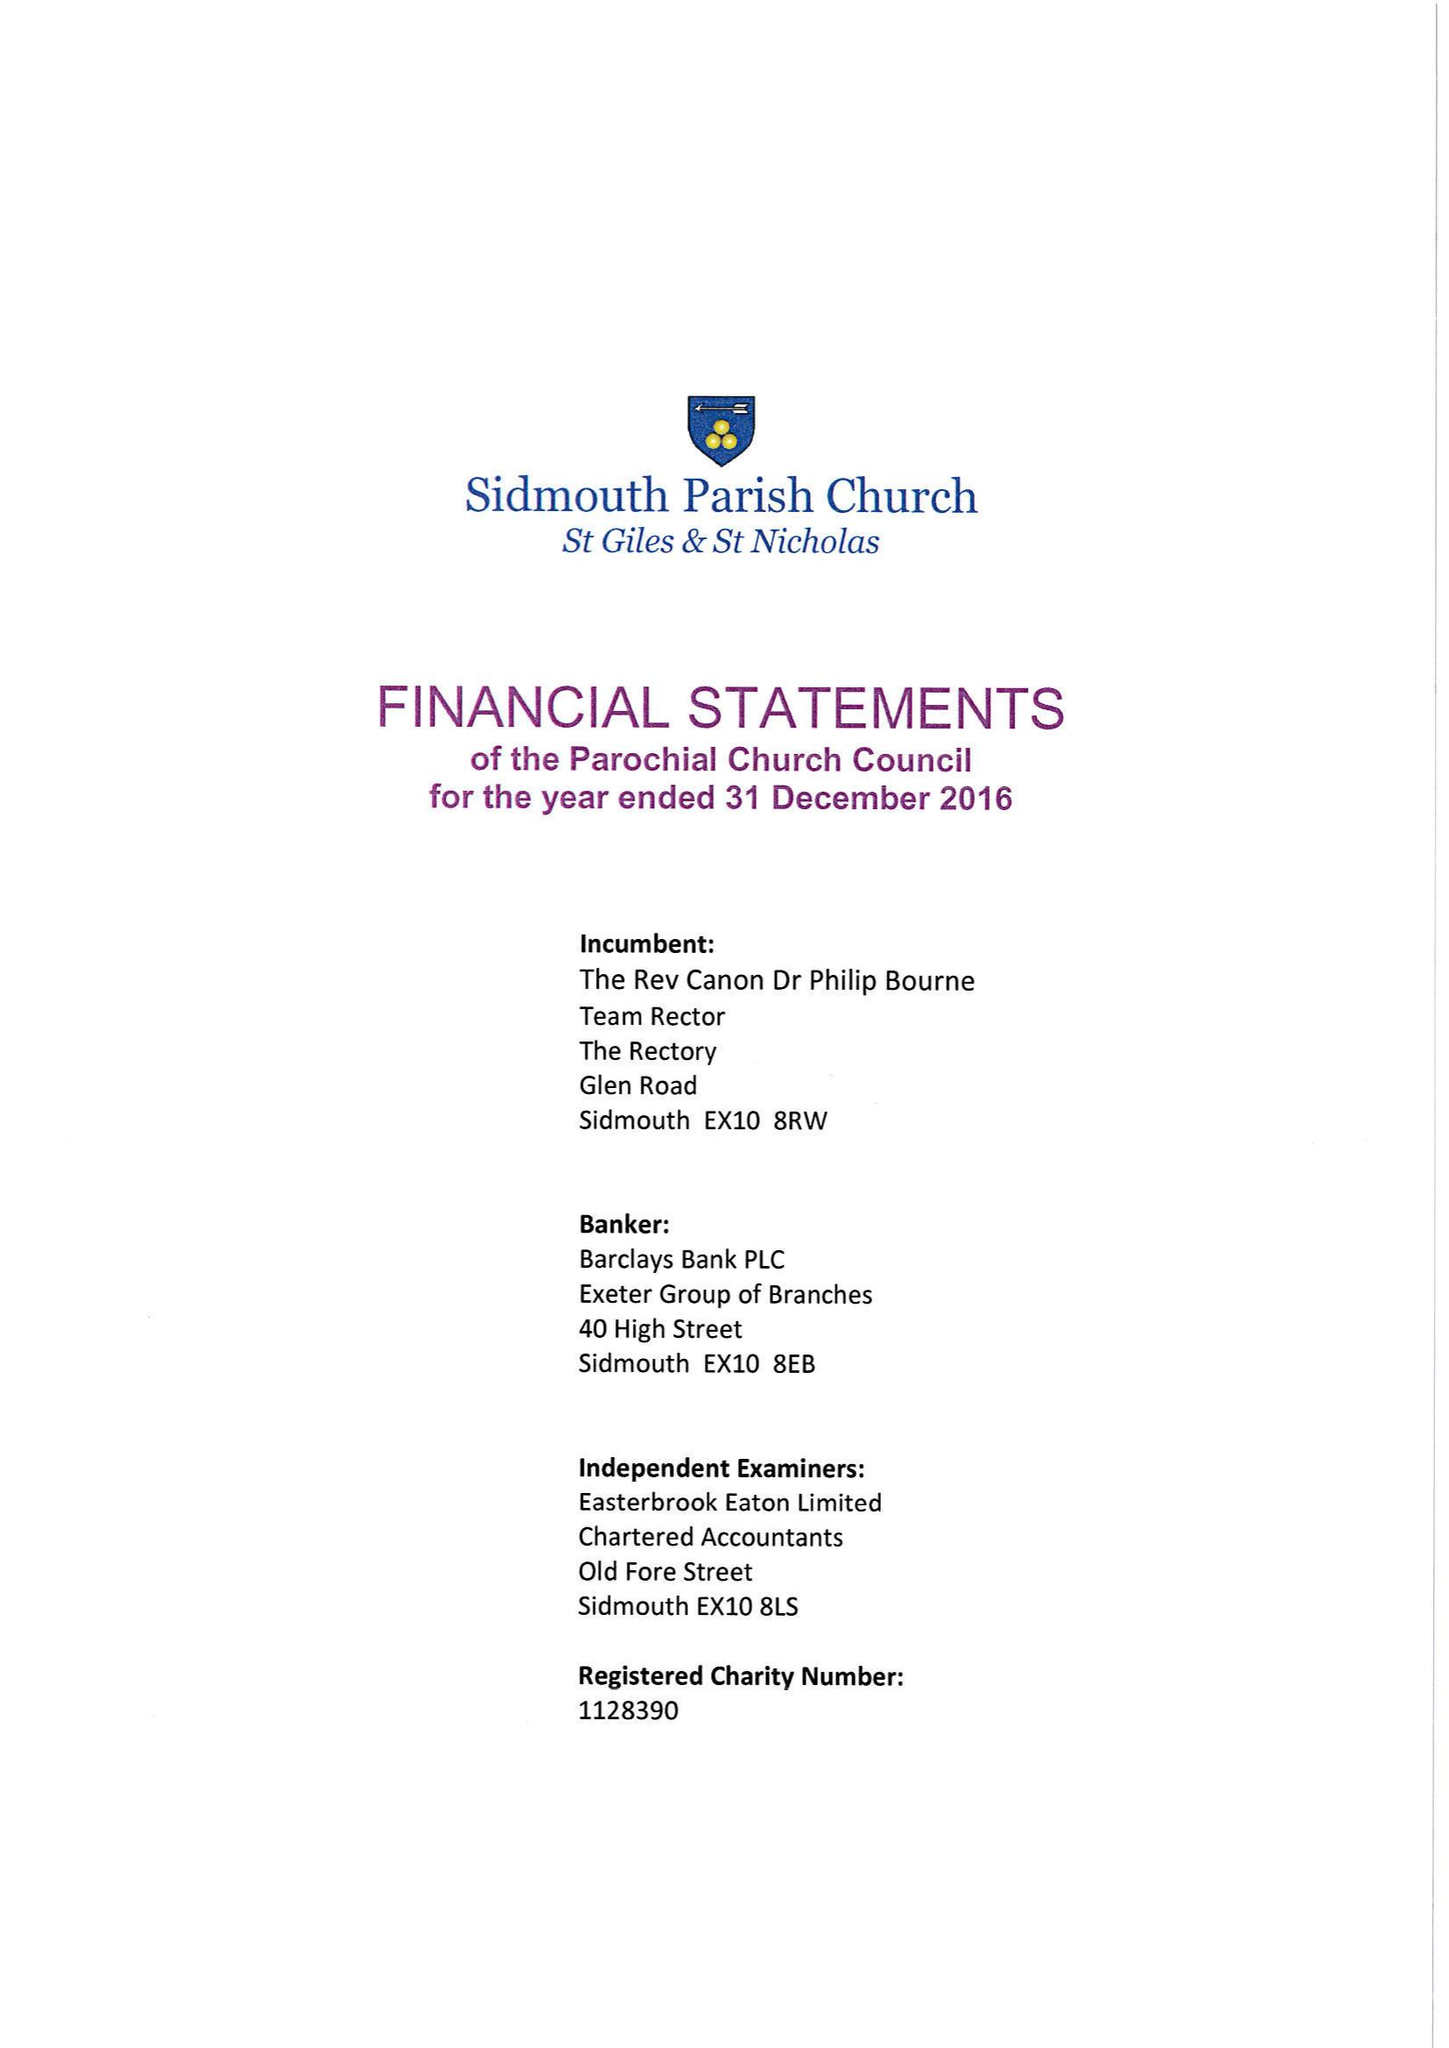What is the value for the address__postcode?
Answer the question using a single word or phrase. EX11 1XJ 